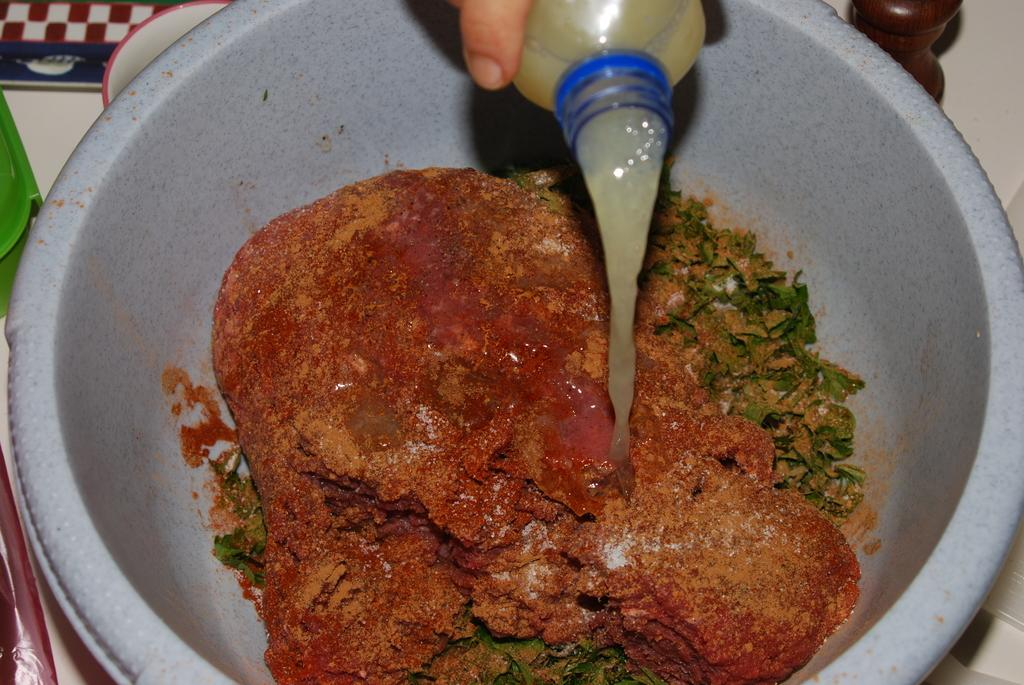What object can be seen in the image that is typically used for holding liquids? There is a bottle in the image. What other object in the image is used for holding or storing items? There is a container in the image. What is inside the container? The container has leaves in it. Are there any other items in the container besides the leaves? Yes, there is another item in the container. Can you describe the presence of a human element in the image? A human hand is visible in the image. What month is being celebrated in the image? There is no indication of a specific month being celebrated in the image. What organization is responsible for the items in the image? There is no organization mentioned or implied in the image. 